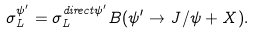Convert formula to latex. <formula><loc_0><loc_0><loc_500><loc_500>\sigma _ { L } ^ { \psi ^ { \prime } } = \sigma _ { L } ^ { d i r e c t \psi ^ { \prime } } B ( \psi ^ { \prime } \to J / \psi + X ) .</formula> 